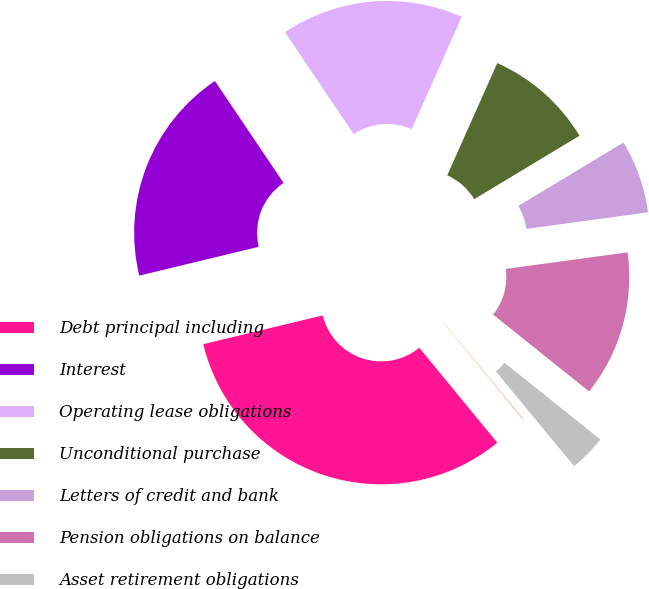Convert chart to OTSL. <chart><loc_0><loc_0><loc_500><loc_500><pie_chart><fcel>Debt principal including<fcel>Interest<fcel>Operating lease obligations<fcel>Unconditional purchase<fcel>Letters of credit and bank<fcel>Pension obligations on balance<fcel>Asset retirement obligations<fcel>Acquisition-related contingent<nl><fcel>32.18%<fcel>19.33%<fcel>16.11%<fcel>9.69%<fcel>6.48%<fcel>12.9%<fcel>3.26%<fcel>0.05%<nl></chart> 